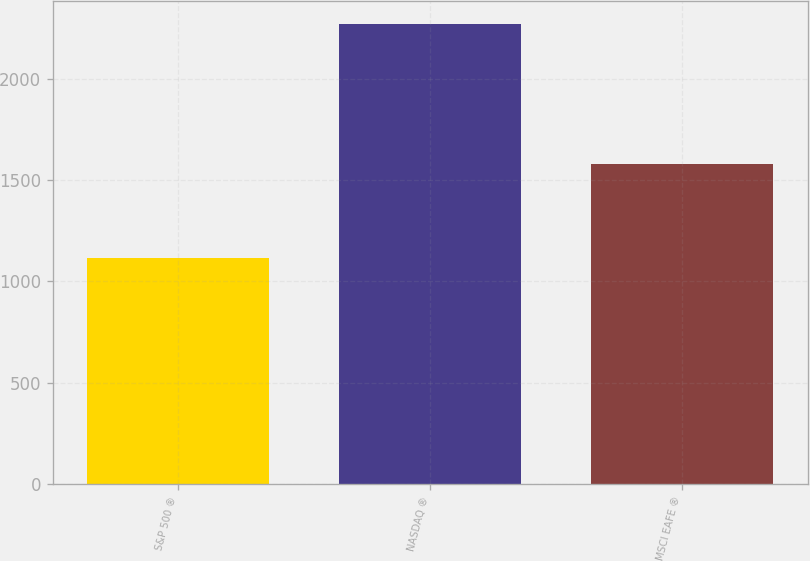Convert chart to OTSL. <chart><loc_0><loc_0><loc_500><loc_500><bar_chart><fcel>S&P 500 ®<fcel>NASDAQ ®<fcel>MSCI EAFE ®<nl><fcel>1115<fcel>2269<fcel>1581<nl></chart> 